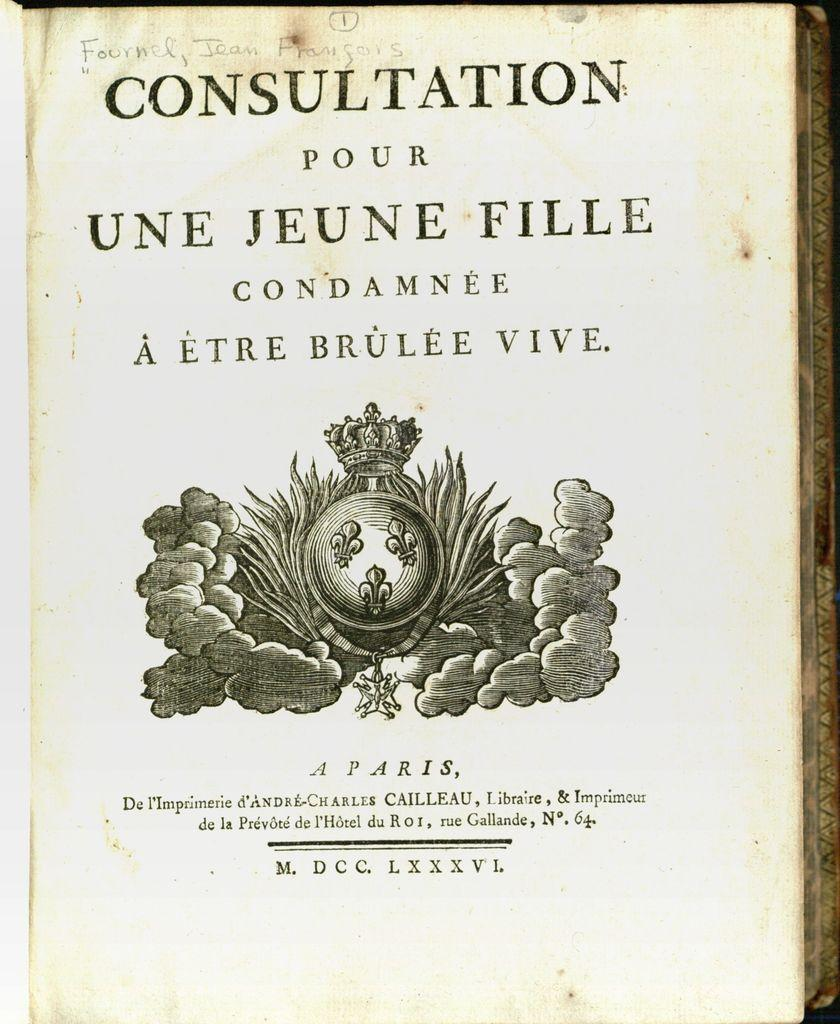<image>
Write a terse but informative summary of the picture. an old book callecd consultation pour une jeune 